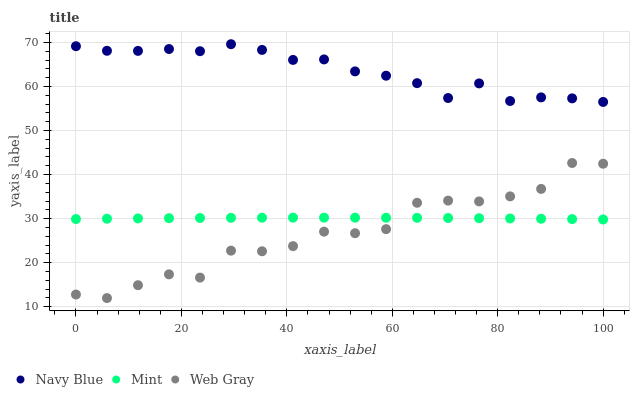Does Web Gray have the minimum area under the curve?
Answer yes or no. Yes. Does Navy Blue have the maximum area under the curve?
Answer yes or no. Yes. Does Mint have the minimum area under the curve?
Answer yes or no. No. Does Mint have the maximum area under the curve?
Answer yes or no. No. Is Mint the smoothest?
Answer yes or no. Yes. Is Web Gray the roughest?
Answer yes or no. Yes. Is Web Gray the smoothest?
Answer yes or no. No. Is Mint the roughest?
Answer yes or no. No. Does Web Gray have the lowest value?
Answer yes or no. Yes. Does Mint have the lowest value?
Answer yes or no. No. Does Navy Blue have the highest value?
Answer yes or no. Yes. Does Web Gray have the highest value?
Answer yes or no. No. Is Web Gray less than Navy Blue?
Answer yes or no. Yes. Is Navy Blue greater than Web Gray?
Answer yes or no. Yes. Does Web Gray intersect Mint?
Answer yes or no. Yes. Is Web Gray less than Mint?
Answer yes or no. No. Is Web Gray greater than Mint?
Answer yes or no. No. Does Web Gray intersect Navy Blue?
Answer yes or no. No. 